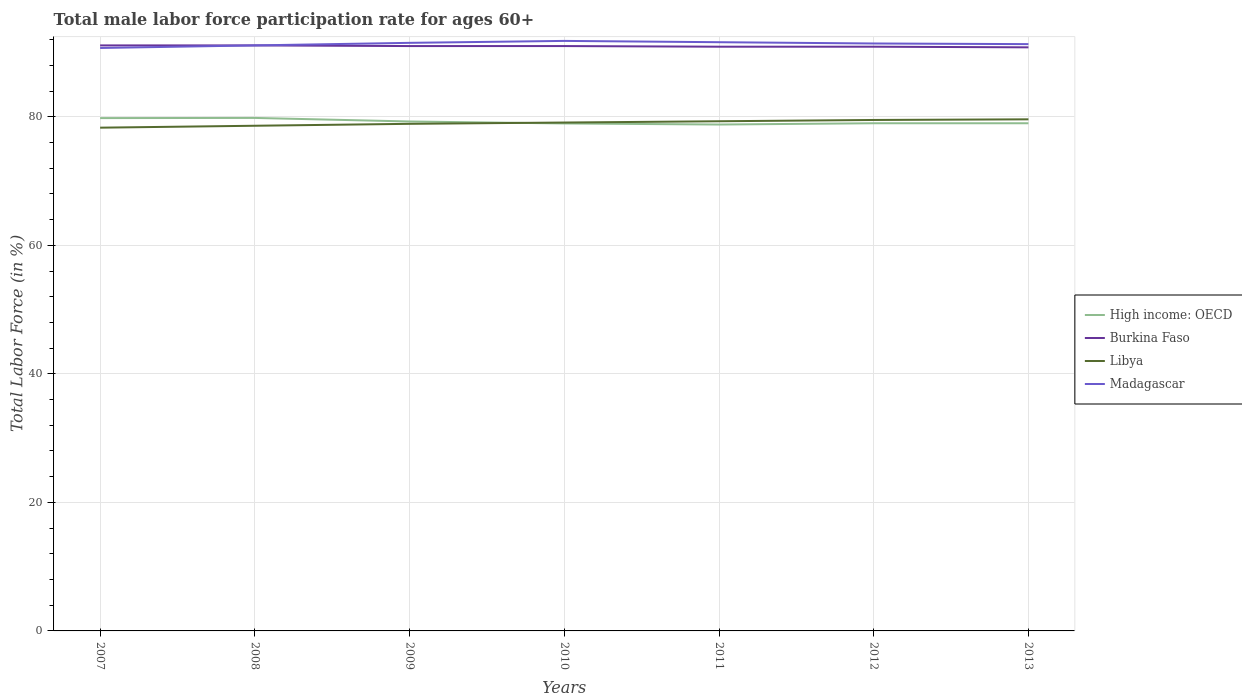Does the line corresponding to Libya intersect with the line corresponding to Madagascar?
Your answer should be very brief. No. Is the number of lines equal to the number of legend labels?
Offer a very short reply. Yes. Across all years, what is the maximum male labor force participation rate in High income: OECD?
Offer a very short reply. 78.79. In which year was the male labor force participation rate in Burkina Faso maximum?
Your response must be concise. 2013. What is the total male labor force participation rate in Burkina Faso in the graph?
Ensure brevity in your answer.  0.1. What is the difference between the highest and the second highest male labor force participation rate in High income: OECD?
Your answer should be very brief. 1.03. Is the male labor force participation rate in Libya strictly greater than the male labor force participation rate in Madagascar over the years?
Provide a succinct answer. Yes. Does the graph contain grids?
Give a very brief answer. Yes. How many legend labels are there?
Provide a succinct answer. 4. What is the title of the graph?
Keep it short and to the point. Total male labor force participation rate for ages 60+. Does "Nepal" appear as one of the legend labels in the graph?
Offer a very short reply. No. What is the label or title of the X-axis?
Your answer should be compact. Years. What is the label or title of the Y-axis?
Your response must be concise. Total Labor Force (in %). What is the Total Labor Force (in %) in High income: OECD in 2007?
Give a very brief answer. 79.79. What is the Total Labor Force (in %) in Burkina Faso in 2007?
Offer a terse response. 91.1. What is the Total Labor Force (in %) in Libya in 2007?
Offer a very short reply. 78.3. What is the Total Labor Force (in %) of Madagascar in 2007?
Keep it short and to the point. 90.7. What is the Total Labor Force (in %) in High income: OECD in 2008?
Make the answer very short. 79.82. What is the Total Labor Force (in %) in Burkina Faso in 2008?
Provide a short and direct response. 91.1. What is the Total Labor Force (in %) in Libya in 2008?
Your answer should be compact. 78.6. What is the Total Labor Force (in %) in Madagascar in 2008?
Ensure brevity in your answer.  91.1. What is the Total Labor Force (in %) of High income: OECD in 2009?
Keep it short and to the point. 79.26. What is the Total Labor Force (in %) in Burkina Faso in 2009?
Give a very brief answer. 91. What is the Total Labor Force (in %) of Libya in 2009?
Provide a succinct answer. 78.9. What is the Total Labor Force (in %) in Madagascar in 2009?
Your response must be concise. 91.5. What is the Total Labor Force (in %) in High income: OECD in 2010?
Make the answer very short. 78.96. What is the Total Labor Force (in %) in Burkina Faso in 2010?
Give a very brief answer. 91. What is the Total Labor Force (in %) in Libya in 2010?
Offer a very short reply. 79.1. What is the Total Labor Force (in %) in Madagascar in 2010?
Offer a terse response. 91.8. What is the Total Labor Force (in %) of High income: OECD in 2011?
Your answer should be compact. 78.79. What is the Total Labor Force (in %) of Burkina Faso in 2011?
Offer a terse response. 90.9. What is the Total Labor Force (in %) of Libya in 2011?
Give a very brief answer. 79.3. What is the Total Labor Force (in %) in Madagascar in 2011?
Offer a very short reply. 91.6. What is the Total Labor Force (in %) in High income: OECD in 2012?
Your response must be concise. 78.99. What is the Total Labor Force (in %) in Burkina Faso in 2012?
Provide a succinct answer. 90.9. What is the Total Labor Force (in %) in Libya in 2012?
Provide a succinct answer. 79.5. What is the Total Labor Force (in %) of Madagascar in 2012?
Offer a terse response. 91.4. What is the Total Labor Force (in %) in High income: OECD in 2013?
Your response must be concise. 78.99. What is the Total Labor Force (in %) of Burkina Faso in 2013?
Make the answer very short. 90.8. What is the Total Labor Force (in %) in Libya in 2013?
Give a very brief answer. 79.6. What is the Total Labor Force (in %) of Madagascar in 2013?
Give a very brief answer. 91.3. Across all years, what is the maximum Total Labor Force (in %) of High income: OECD?
Offer a terse response. 79.82. Across all years, what is the maximum Total Labor Force (in %) in Burkina Faso?
Give a very brief answer. 91.1. Across all years, what is the maximum Total Labor Force (in %) in Libya?
Make the answer very short. 79.6. Across all years, what is the maximum Total Labor Force (in %) of Madagascar?
Offer a very short reply. 91.8. Across all years, what is the minimum Total Labor Force (in %) of High income: OECD?
Offer a very short reply. 78.79. Across all years, what is the minimum Total Labor Force (in %) in Burkina Faso?
Give a very brief answer. 90.8. Across all years, what is the minimum Total Labor Force (in %) in Libya?
Provide a succinct answer. 78.3. Across all years, what is the minimum Total Labor Force (in %) of Madagascar?
Give a very brief answer. 90.7. What is the total Total Labor Force (in %) in High income: OECD in the graph?
Provide a succinct answer. 554.6. What is the total Total Labor Force (in %) of Burkina Faso in the graph?
Offer a very short reply. 636.8. What is the total Total Labor Force (in %) in Libya in the graph?
Keep it short and to the point. 553.3. What is the total Total Labor Force (in %) in Madagascar in the graph?
Offer a terse response. 639.4. What is the difference between the Total Labor Force (in %) of High income: OECD in 2007 and that in 2008?
Your answer should be compact. -0.03. What is the difference between the Total Labor Force (in %) in Libya in 2007 and that in 2008?
Keep it short and to the point. -0.3. What is the difference between the Total Labor Force (in %) in Madagascar in 2007 and that in 2008?
Make the answer very short. -0.4. What is the difference between the Total Labor Force (in %) of High income: OECD in 2007 and that in 2009?
Your answer should be compact. 0.53. What is the difference between the Total Labor Force (in %) of Burkina Faso in 2007 and that in 2009?
Make the answer very short. 0.1. What is the difference between the Total Labor Force (in %) of Madagascar in 2007 and that in 2009?
Offer a very short reply. -0.8. What is the difference between the Total Labor Force (in %) in High income: OECD in 2007 and that in 2010?
Provide a short and direct response. 0.83. What is the difference between the Total Labor Force (in %) of High income: OECD in 2007 and that in 2011?
Make the answer very short. 1. What is the difference between the Total Labor Force (in %) in Burkina Faso in 2007 and that in 2011?
Offer a very short reply. 0.2. What is the difference between the Total Labor Force (in %) of Libya in 2007 and that in 2011?
Offer a terse response. -1. What is the difference between the Total Labor Force (in %) in High income: OECD in 2007 and that in 2012?
Your answer should be compact. 0.8. What is the difference between the Total Labor Force (in %) of Burkina Faso in 2007 and that in 2012?
Your response must be concise. 0.2. What is the difference between the Total Labor Force (in %) of Libya in 2007 and that in 2012?
Your answer should be compact. -1.2. What is the difference between the Total Labor Force (in %) of Madagascar in 2007 and that in 2012?
Ensure brevity in your answer.  -0.7. What is the difference between the Total Labor Force (in %) of High income: OECD in 2007 and that in 2013?
Make the answer very short. 0.8. What is the difference between the Total Labor Force (in %) of Burkina Faso in 2007 and that in 2013?
Make the answer very short. 0.3. What is the difference between the Total Labor Force (in %) in Libya in 2007 and that in 2013?
Your answer should be compact. -1.3. What is the difference between the Total Labor Force (in %) in High income: OECD in 2008 and that in 2009?
Your answer should be compact. 0.56. What is the difference between the Total Labor Force (in %) in High income: OECD in 2008 and that in 2010?
Offer a terse response. 0.86. What is the difference between the Total Labor Force (in %) in Libya in 2008 and that in 2010?
Make the answer very short. -0.5. What is the difference between the Total Labor Force (in %) in High income: OECD in 2008 and that in 2011?
Provide a short and direct response. 1.03. What is the difference between the Total Labor Force (in %) of Burkina Faso in 2008 and that in 2011?
Your answer should be compact. 0.2. What is the difference between the Total Labor Force (in %) of High income: OECD in 2008 and that in 2012?
Offer a very short reply. 0.83. What is the difference between the Total Labor Force (in %) of Burkina Faso in 2008 and that in 2012?
Your answer should be very brief. 0.2. What is the difference between the Total Labor Force (in %) in Libya in 2008 and that in 2012?
Make the answer very short. -0.9. What is the difference between the Total Labor Force (in %) in Madagascar in 2008 and that in 2012?
Provide a succinct answer. -0.3. What is the difference between the Total Labor Force (in %) of High income: OECD in 2008 and that in 2013?
Offer a terse response. 0.83. What is the difference between the Total Labor Force (in %) in Burkina Faso in 2008 and that in 2013?
Ensure brevity in your answer.  0.3. What is the difference between the Total Labor Force (in %) in High income: OECD in 2009 and that in 2010?
Provide a short and direct response. 0.31. What is the difference between the Total Labor Force (in %) of High income: OECD in 2009 and that in 2011?
Offer a very short reply. 0.47. What is the difference between the Total Labor Force (in %) of Libya in 2009 and that in 2011?
Provide a short and direct response. -0.4. What is the difference between the Total Labor Force (in %) in High income: OECD in 2009 and that in 2012?
Your response must be concise. 0.28. What is the difference between the Total Labor Force (in %) in Madagascar in 2009 and that in 2012?
Ensure brevity in your answer.  0.1. What is the difference between the Total Labor Force (in %) in High income: OECD in 2009 and that in 2013?
Provide a short and direct response. 0.27. What is the difference between the Total Labor Force (in %) in Libya in 2009 and that in 2013?
Your response must be concise. -0.7. What is the difference between the Total Labor Force (in %) of High income: OECD in 2010 and that in 2011?
Keep it short and to the point. 0.17. What is the difference between the Total Labor Force (in %) in Libya in 2010 and that in 2011?
Your answer should be compact. -0.2. What is the difference between the Total Labor Force (in %) of Madagascar in 2010 and that in 2011?
Your response must be concise. 0.2. What is the difference between the Total Labor Force (in %) in High income: OECD in 2010 and that in 2012?
Provide a short and direct response. -0.03. What is the difference between the Total Labor Force (in %) in Libya in 2010 and that in 2012?
Ensure brevity in your answer.  -0.4. What is the difference between the Total Labor Force (in %) in High income: OECD in 2010 and that in 2013?
Ensure brevity in your answer.  -0.03. What is the difference between the Total Labor Force (in %) of Burkina Faso in 2010 and that in 2013?
Provide a succinct answer. 0.2. What is the difference between the Total Labor Force (in %) in High income: OECD in 2011 and that in 2012?
Give a very brief answer. -0.2. What is the difference between the Total Labor Force (in %) in High income: OECD in 2011 and that in 2013?
Offer a very short reply. -0.2. What is the difference between the Total Labor Force (in %) of Burkina Faso in 2011 and that in 2013?
Offer a terse response. 0.1. What is the difference between the Total Labor Force (in %) in Madagascar in 2011 and that in 2013?
Keep it short and to the point. 0.3. What is the difference between the Total Labor Force (in %) in High income: OECD in 2012 and that in 2013?
Your answer should be compact. -0. What is the difference between the Total Labor Force (in %) of Libya in 2012 and that in 2013?
Keep it short and to the point. -0.1. What is the difference between the Total Labor Force (in %) of High income: OECD in 2007 and the Total Labor Force (in %) of Burkina Faso in 2008?
Give a very brief answer. -11.31. What is the difference between the Total Labor Force (in %) of High income: OECD in 2007 and the Total Labor Force (in %) of Libya in 2008?
Your answer should be compact. 1.19. What is the difference between the Total Labor Force (in %) in High income: OECD in 2007 and the Total Labor Force (in %) in Madagascar in 2008?
Provide a short and direct response. -11.31. What is the difference between the Total Labor Force (in %) of Libya in 2007 and the Total Labor Force (in %) of Madagascar in 2008?
Your answer should be very brief. -12.8. What is the difference between the Total Labor Force (in %) in High income: OECD in 2007 and the Total Labor Force (in %) in Burkina Faso in 2009?
Ensure brevity in your answer.  -11.21. What is the difference between the Total Labor Force (in %) of High income: OECD in 2007 and the Total Labor Force (in %) of Libya in 2009?
Offer a terse response. 0.89. What is the difference between the Total Labor Force (in %) of High income: OECD in 2007 and the Total Labor Force (in %) of Madagascar in 2009?
Offer a terse response. -11.71. What is the difference between the Total Labor Force (in %) of Burkina Faso in 2007 and the Total Labor Force (in %) of Madagascar in 2009?
Provide a short and direct response. -0.4. What is the difference between the Total Labor Force (in %) in High income: OECD in 2007 and the Total Labor Force (in %) in Burkina Faso in 2010?
Your answer should be compact. -11.21. What is the difference between the Total Labor Force (in %) of High income: OECD in 2007 and the Total Labor Force (in %) of Libya in 2010?
Provide a short and direct response. 0.69. What is the difference between the Total Labor Force (in %) of High income: OECD in 2007 and the Total Labor Force (in %) of Madagascar in 2010?
Provide a short and direct response. -12.01. What is the difference between the Total Labor Force (in %) in Libya in 2007 and the Total Labor Force (in %) in Madagascar in 2010?
Offer a very short reply. -13.5. What is the difference between the Total Labor Force (in %) in High income: OECD in 2007 and the Total Labor Force (in %) in Burkina Faso in 2011?
Your answer should be compact. -11.11. What is the difference between the Total Labor Force (in %) of High income: OECD in 2007 and the Total Labor Force (in %) of Libya in 2011?
Your answer should be very brief. 0.49. What is the difference between the Total Labor Force (in %) of High income: OECD in 2007 and the Total Labor Force (in %) of Madagascar in 2011?
Your answer should be very brief. -11.81. What is the difference between the Total Labor Force (in %) in Burkina Faso in 2007 and the Total Labor Force (in %) in Madagascar in 2011?
Provide a succinct answer. -0.5. What is the difference between the Total Labor Force (in %) of Libya in 2007 and the Total Labor Force (in %) of Madagascar in 2011?
Offer a terse response. -13.3. What is the difference between the Total Labor Force (in %) in High income: OECD in 2007 and the Total Labor Force (in %) in Burkina Faso in 2012?
Your response must be concise. -11.11. What is the difference between the Total Labor Force (in %) in High income: OECD in 2007 and the Total Labor Force (in %) in Libya in 2012?
Provide a succinct answer. 0.29. What is the difference between the Total Labor Force (in %) of High income: OECD in 2007 and the Total Labor Force (in %) of Madagascar in 2012?
Offer a very short reply. -11.61. What is the difference between the Total Labor Force (in %) of Burkina Faso in 2007 and the Total Labor Force (in %) of Libya in 2012?
Make the answer very short. 11.6. What is the difference between the Total Labor Force (in %) of Burkina Faso in 2007 and the Total Labor Force (in %) of Madagascar in 2012?
Your answer should be compact. -0.3. What is the difference between the Total Labor Force (in %) in Libya in 2007 and the Total Labor Force (in %) in Madagascar in 2012?
Offer a very short reply. -13.1. What is the difference between the Total Labor Force (in %) in High income: OECD in 2007 and the Total Labor Force (in %) in Burkina Faso in 2013?
Make the answer very short. -11.01. What is the difference between the Total Labor Force (in %) of High income: OECD in 2007 and the Total Labor Force (in %) of Libya in 2013?
Make the answer very short. 0.19. What is the difference between the Total Labor Force (in %) in High income: OECD in 2007 and the Total Labor Force (in %) in Madagascar in 2013?
Your answer should be compact. -11.51. What is the difference between the Total Labor Force (in %) of Burkina Faso in 2007 and the Total Labor Force (in %) of Libya in 2013?
Offer a very short reply. 11.5. What is the difference between the Total Labor Force (in %) in Burkina Faso in 2007 and the Total Labor Force (in %) in Madagascar in 2013?
Your response must be concise. -0.2. What is the difference between the Total Labor Force (in %) of Libya in 2007 and the Total Labor Force (in %) of Madagascar in 2013?
Give a very brief answer. -13. What is the difference between the Total Labor Force (in %) in High income: OECD in 2008 and the Total Labor Force (in %) in Burkina Faso in 2009?
Provide a short and direct response. -11.18. What is the difference between the Total Labor Force (in %) of High income: OECD in 2008 and the Total Labor Force (in %) of Libya in 2009?
Give a very brief answer. 0.92. What is the difference between the Total Labor Force (in %) in High income: OECD in 2008 and the Total Labor Force (in %) in Madagascar in 2009?
Provide a succinct answer. -11.68. What is the difference between the Total Labor Force (in %) of Burkina Faso in 2008 and the Total Labor Force (in %) of Madagascar in 2009?
Provide a short and direct response. -0.4. What is the difference between the Total Labor Force (in %) of Libya in 2008 and the Total Labor Force (in %) of Madagascar in 2009?
Offer a terse response. -12.9. What is the difference between the Total Labor Force (in %) in High income: OECD in 2008 and the Total Labor Force (in %) in Burkina Faso in 2010?
Keep it short and to the point. -11.18. What is the difference between the Total Labor Force (in %) in High income: OECD in 2008 and the Total Labor Force (in %) in Libya in 2010?
Offer a very short reply. 0.72. What is the difference between the Total Labor Force (in %) in High income: OECD in 2008 and the Total Labor Force (in %) in Madagascar in 2010?
Give a very brief answer. -11.98. What is the difference between the Total Labor Force (in %) of Burkina Faso in 2008 and the Total Labor Force (in %) of Madagascar in 2010?
Your answer should be compact. -0.7. What is the difference between the Total Labor Force (in %) of Libya in 2008 and the Total Labor Force (in %) of Madagascar in 2010?
Offer a terse response. -13.2. What is the difference between the Total Labor Force (in %) in High income: OECD in 2008 and the Total Labor Force (in %) in Burkina Faso in 2011?
Offer a very short reply. -11.08. What is the difference between the Total Labor Force (in %) in High income: OECD in 2008 and the Total Labor Force (in %) in Libya in 2011?
Your answer should be very brief. 0.52. What is the difference between the Total Labor Force (in %) of High income: OECD in 2008 and the Total Labor Force (in %) of Madagascar in 2011?
Your response must be concise. -11.78. What is the difference between the Total Labor Force (in %) of Burkina Faso in 2008 and the Total Labor Force (in %) of Libya in 2011?
Make the answer very short. 11.8. What is the difference between the Total Labor Force (in %) in Burkina Faso in 2008 and the Total Labor Force (in %) in Madagascar in 2011?
Make the answer very short. -0.5. What is the difference between the Total Labor Force (in %) of Libya in 2008 and the Total Labor Force (in %) of Madagascar in 2011?
Offer a very short reply. -13. What is the difference between the Total Labor Force (in %) of High income: OECD in 2008 and the Total Labor Force (in %) of Burkina Faso in 2012?
Your answer should be very brief. -11.08. What is the difference between the Total Labor Force (in %) of High income: OECD in 2008 and the Total Labor Force (in %) of Libya in 2012?
Provide a succinct answer. 0.32. What is the difference between the Total Labor Force (in %) of High income: OECD in 2008 and the Total Labor Force (in %) of Madagascar in 2012?
Your answer should be very brief. -11.58. What is the difference between the Total Labor Force (in %) of High income: OECD in 2008 and the Total Labor Force (in %) of Burkina Faso in 2013?
Your answer should be compact. -10.98. What is the difference between the Total Labor Force (in %) of High income: OECD in 2008 and the Total Labor Force (in %) of Libya in 2013?
Keep it short and to the point. 0.22. What is the difference between the Total Labor Force (in %) in High income: OECD in 2008 and the Total Labor Force (in %) in Madagascar in 2013?
Provide a short and direct response. -11.48. What is the difference between the Total Labor Force (in %) of Burkina Faso in 2008 and the Total Labor Force (in %) of Madagascar in 2013?
Keep it short and to the point. -0.2. What is the difference between the Total Labor Force (in %) in Libya in 2008 and the Total Labor Force (in %) in Madagascar in 2013?
Give a very brief answer. -12.7. What is the difference between the Total Labor Force (in %) in High income: OECD in 2009 and the Total Labor Force (in %) in Burkina Faso in 2010?
Provide a short and direct response. -11.74. What is the difference between the Total Labor Force (in %) in High income: OECD in 2009 and the Total Labor Force (in %) in Libya in 2010?
Provide a short and direct response. 0.16. What is the difference between the Total Labor Force (in %) of High income: OECD in 2009 and the Total Labor Force (in %) of Madagascar in 2010?
Provide a short and direct response. -12.54. What is the difference between the Total Labor Force (in %) in Burkina Faso in 2009 and the Total Labor Force (in %) in Madagascar in 2010?
Provide a short and direct response. -0.8. What is the difference between the Total Labor Force (in %) of High income: OECD in 2009 and the Total Labor Force (in %) of Burkina Faso in 2011?
Give a very brief answer. -11.64. What is the difference between the Total Labor Force (in %) in High income: OECD in 2009 and the Total Labor Force (in %) in Libya in 2011?
Offer a terse response. -0.04. What is the difference between the Total Labor Force (in %) in High income: OECD in 2009 and the Total Labor Force (in %) in Madagascar in 2011?
Offer a very short reply. -12.34. What is the difference between the Total Labor Force (in %) in Burkina Faso in 2009 and the Total Labor Force (in %) in Libya in 2011?
Provide a short and direct response. 11.7. What is the difference between the Total Labor Force (in %) of Burkina Faso in 2009 and the Total Labor Force (in %) of Madagascar in 2011?
Offer a very short reply. -0.6. What is the difference between the Total Labor Force (in %) in High income: OECD in 2009 and the Total Labor Force (in %) in Burkina Faso in 2012?
Keep it short and to the point. -11.64. What is the difference between the Total Labor Force (in %) in High income: OECD in 2009 and the Total Labor Force (in %) in Libya in 2012?
Offer a terse response. -0.24. What is the difference between the Total Labor Force (in %) in High income: OECD in 2009 and the Total Labor Force (in %) in Madagascar in 2012?
Offer a very short reply. -12.14. What is the difference between the Total Labor Force (in %) in Libya in 2009 and the Total Labor Force (in %) in Madagascar in 2012?
Give a very brief answer. -12.5. What is the difference between the Total Labor Force (in %) in High income: OECD in 2009 and the Total Labor Force (in %) in Burkina Faso in 2013?
Your answer should be very brief. -11.54. What is the difference between the Total Labor Force (in %) in High income: OECD in 2009 and the Total Labor Force (in %) in Libya in 2013?
Offer a terse response. -0.34. What is the difference between the Total Labor Force (in %) in High income: OECD in 2009 and the Total Labor Force (in %) in Madagascar in 2013?
Offer a terse response. -12.04. What is the difference between the Total Labor Force (in %) of Libya in 2009 and the Total Labor Force (in %) of Madagascar in 2013?
Provide a succinct answer. -12.4. What is the difference between the Total Labor Force (in %) of High income: OECD in 2010 and the Total Labor Force (in %) of Burkina Faso in 2011?
Your answer should be compact. -11.94. What is the difference between the Total Labor Force (in %) of High income: OECD in 2010 and the Total Labor Force (in %) of Libya in 2011?
Provide a succinct answer. -0.34. What is the difference between the Total Labor Force (in %) in High income: OECD in 2010 and the Total Labor Force (in %) in Madagascar in 2011?
Offer a terse response. -12.64. What is the difference between the Total Labor Force (in %) of Burkina Faso in 2010 and the Total Labor Force (in %) of Madagascar in 2011?
Your answer should be compact. -0.6. What is the difference between the Total Labor Force (in %) in High income: OECD in 2010 and the Total Labor Force (in %) in Burkina Faso in 2012?
Keep it short and to the point. -11.94. What is the difference between the Total Labor Force (in %) in High income: OECD in 2010 and the Total Labor Force (in %) in Libya in 2012?
Make the answer very short. -0.54. What is the difference between the Total Labor Force (in %) of High income: OECD in 2010 and the Total Labor Force (in %) of Madagascar in 2012?
Provide a short and direct response. -12.44. What is the difference between the Total Labor Force (in %) of Burkina Faso in 2010 and the Total Labor Force (in %) of Libya in 2012?
Keep it short and to the point. 11.5. What is the difference between the Total Labor Force (in %) in High income: OECD in 2010 and the Total Labor Force (in %) in Burkina Faso in 2013?
Provide a short and direct response. -11.84. What is the difference between the Total Labor Force (in %) of High income: OECD in 2010 and the Total Labor Force (in %) of Libya in 2013?
Give a very brief answer. -0.64. What is the difference between the Total Labor Force (in %) of High income: OECD in 2010 and the Total Labor Force (in %) of Madagascar in 2013?
Keep it short and to the point. -12.34. What is the difference between the Total Labor Force (in %) in High income: OECD in 2011 and the Total Labor Force (in %) in Burkina Faso in 2012?
Your response must be concise. -12.11. What is the difference between the Total Labor Force (in %) in High income: OECD in 2011 and the Total Labor Force (in %) in Libya in 2012?
Your response must be concise. -0.71. What is the difference between the Total Labor Force (in %) in High income: OECD in 2011 and the Total Labor Force (in %) in Madagascar in 2012?
Provide a short and direct response. -12.61. What is the difference between the Total Labor Force (in %) of Burkina Faso in 2011 and the Total Labor Force (in %) of Madagascar in 2012?
Give a very brief answer. -0.5. What is the difference between the Total Labor Force (in %) of Libya in 2011 and the Total Labor Force (in %) of Madagascar in 2012?
Keep it short and to the point. -12.1. What is the difference between the Total Labor Force (in %) in High income: OECD in 2011 and the Total Labor Force (in %) in Burkina Faso in 2013?
Offer a terse response. -12.01. What is the difference between the Total Labor Force (in %) of High income: OECD in 2011 and the Total Labor Force (in %) of Libya in 2013?
Give a very brief answer. -0.81. What is the difference between the Total Labor Force (in %) in High income: OECD in 2011 and the Total Labor Force (in %) in Madagascar in 2013?
Ensure brevity in your answer.  -12.51. What is the difference between the Total Labor Force (in %) in Burkina Faso in 2011 and the Total Labor Force (in %) in Madagascar in 2013?
Ensure brevity in your answer.  -0.4. What is the difference between the Total Labor Force (in %) of High income: OECD in 2012 and the Total Labor Force (in %) of Burkina Faso in 2013?
Provide a succinct answer. -11.81. What is the difference between the Total Labor Force (in %) of High income: OECD in 2012 and the Total Labor Force (in %) of Libya in 2013?
Your answer should be compact. -0.61. What is the difference between the Total Labor Force (in %) of High income: OECD in 2012 and the Total Labor Force (in %) of Madagascar in 2013?
Your answer should be compact. -12.31. What is the difference between the Total Labor Force (in %) of Burkina Faso in 2012 and the Total Labor Force (in %) of Libya in 2013?
Offer a terse response. 11.3. What is the average Total Labor Force (in %) of High income: OECD per year?
Your answer should be very brief. 79.23. What is the average Total Labor Force (in %) in Burkina Faso per year?
Give a very brief answer. 90.97. What is the average Total Labor Force (in %) of Libya per year?
Make the answer very short. 79.04. What is the average Total Labor Force (in %) of Madagascar per year?
Provide a short and direct response. 91.34. In the year 2007, what is the difference between the Total Labor Force (in %) in High income: OECD and Total Labor Force (in %) in Burkina Faso?
Your answer should be compact. -11.31. In the year 2007, what is the difference between the Total Labor Force (in %) in High income: OECD and Total Labor Force (in %) in Libya?
Offer a terse response. 1.49. In the year 2007, what is the difference between the Total Labor Force (in %) of High income: OECD and Total Labor Force (in %) of Madagascar?
Your response must be concise. -10.91. In the year 2008, what is the difference between the Total Labor Force (in %) of High income: OECD and Total Labor Force (in %) of Burkina Faso?
Offer a terse response. -11.28. In the year 2008, what is the difference between the Total Labor Force (in %) in High income: OECD and Total Labor Force (in %) in Libya?
Offer a terse response. 1.22. In the year 2008, what is the difference between the Total Labor Force (in %) in High income: OECD and Total Labor Force (in %) in Madagascar?
Make the answer very short. -11.28. In the year 2008, what is the difference between the Total Labor Force (in %) of Burkina Faso and Total Labor Force (in %) of Madagascar?
Keep it short and to the point. 0. In the year 2008, what is the difference between the Total Labor Force (in %) in Libya and Total Labor Force (in %) in Madagascar?
Give a very brief answer. -12.5. In the year 2009, what is the difference between the Total Labor Force (in %) in High income: OECD and Total Labor Force (in %) in Burkina Faso?
Make the answer very short. -11.74. In the year 2009, what is the difference between the Total Labor Force (in %) of High income: OECD and Total Labor Force (in %) of Libya?
Provide a short and direct response. 0.36. In the year 2009, what is the difference between the Total Labor Force (in %) of High income: OECD and Total Labor Force (in %) of Madagascar?
Provide a short and direct response. -12.24. In the year 2010, what is the difference between the Total Labor Force (in %) of High income: OECD and Total Labor Force (in %) of Burkina Faso?
Your answer should be compact. -12.04. In the year 2010, what is the difference between the Total Labor Force (in %) of High income: OECD and Total Labor Force (in %) of Libya?
Your answer should be very brief. -0.14. In the year 2010, what is the difference between the Total Labor Force (in %) in High income: OECD and Total Labor Force (in %) in Madagascar?
Keep it short and to the point. -12.84. In the year 2010, what is the difference between the Total Labor Force (in %) of Burkina Faso and Total Labor Force (in %) of Libya?
Your answer should be very brief. 11.9. In the year 2010, what is the difference between the Total Labor Force (in %) of Burkina Faso and Total Labor Force (in %) of Madagascar?
Make the answer very short. -0.8. In the year 2010, what is the difference between the Total Labor Force (in %) of Libya and Total Labor Force (in %) of Madagascar?
Your answer should be compact. -12.7. In the year 2011, what is the difference between the Total Labor Force (in %) of High income: OECD and Total Labor Force (in %) of Burkina Faso?
Keep it short and to the point. -12.11. In the year 2011, what is the difference between the Total Labor Force (in %) of High income: OECD and Total Labor Force (in %) of Libya?
Give a very brief answer. -0.51. In the year 2011, what is the difference between the Total Labor Force (in %) in High income: OECD and Total Labor Force (in %) in Madagascar?
Offer a terse response. -12.81. In the year 2011, what is the difference between the Total Labor Force (in %) of Burkina Faso and Total Labor Force (in %) of Libya?
Your response must be concise. 11.6. In the year 2012, what is the difference between the Total Labor Force (in %) of High income: OECD and Total Labor Force (in %) of Burkina Faso?
Your response must be concise. -11.91. In the year 2012, what is the difference between the Total Labor Force (in %) of High income: OECD and Total Labor Force (in %) of Libya?
Your response must be concise. -0.51. In the year 2012, what is the difference between the Total Labor Force (in %) in High income: OECD and Total Labor Force (in %) in Madagascar?
Offer a very short reply. -12.41. In the year 2012, what is the difference between the Total Labor Force (in %) in Burkina Faso and Total Labor Force (in %) in Libya?
Your response must be concise. 11.4. In the year 2012, what is the difference between the Total Labor Force (in %) in Burkina Faso and Total Labor Force (in %) in Madagascar?
Your answer should be very brief. -0.5. In the year 2012, what is the difference between the Total Labor Force (in %) of Libya and Total Labor Force (in %) of Madagascar?
Make the answer very short. -11.9. In the year 2013, what is the difference between the Total Labor Force (in %) of High income: OECD and Total Labor Force (in %) of Burkina Faso?
Offer a very short reply. -11.81. In the year 2013, what is the difference between the Total Labor Force (in %) of High income: OECD and Total Labor Force (in %) of Libya?
Give a very brief answer. -0.61. In the year 2013, what is the difference between the Total Labor Force (in %) of High income: OECD and Total Labor Force (in %) of Madagascar?
Offer a very short reply. -12.31. In the year 2013, what is the difference between the Total Labor Force (in %) in Burkina Faso and Total Labor Force (in %) in Libya?
Your answer should be compact. 11.2. In the year 2013, what is the difference between the Total Labor Force (in %) in Burkina Faso and Total Labor Force (in %) in Madagascar?
Your answer should be compact. -0.5. In the year 2013, what is the difference between the Total Labor Force (in %) of Libya and Total Labor Force (in %) of Madagascar?
Give a very brief answer. -11.7. What is the ratio of the Total Labor Force (in %) in High income: OECD in 2007 to that in 2008?
Your response must be concise. 1. What is the ratio of the Total Labor Force (in %) of Burkina Faso in 2007 to that in 2008?
Provide a succinct answer. 1. What is the ratio of the Total Labor Force (in %) of Madagascar in 2007 to that in 2008?
Make the answer very short. 1. What is the ratio of the Total Labor Force (in %) in Burkina Faso in 2007 to that in 2009?
Provide a short and direct response. 1. What is the ratio of the Total Labor Force (in %) in Libya in 2007 to that in 2009?
Give a very brief answer. 0.99. What is the ratio of the Total Labor Force (in %) in Madagascar in 2007 to that in 2009?
Your response must be concise. 0.99. What is the ratio of the Total Labor Force (in %) in High income: OECD in 2007 to that in 2010?
Provide a succinct answer. 1.01. What is the ratio of the Total Labor Force (in %) in Burkina Faso in 2007 to that in 2010?
Keep it short and to the point. 1. What is the ratio of the Total Labor Force (in %) in Libya in 2007 to that in 2010?
Offer a very short reply. 0.99. What is the ratio of the Total Labor Force (in %) of Madagascar in 2007 to that in 2010?
Offer a very short reply. 0.99. What is the ratio of the Total Labor Force (in %) of High income: OECD in 2007 to that in 2011?
Make the answer very short. 1.01. What is the ratio of the Total Labor Force (in %) of Burkina Faso in 2007 to that in 2011?
Keep it short and to the point. 1. What is the ratio of the Total Labor Force (in %) of Libya in 2007 to that in 2011?
Offer a very short reply. 0.99. What is the ratio of the Total Labor Force (in %) in Madagascar in 2007 to that in 2011?
Your answer should be very brief. 0.99. What is the ratio of the Total Labor Force (in %) in High income: OECD in 2007 to that in 2012?
Ensure brevity in your answer.  1.01. What is the ratio of the Total Labor Force (in %) of Libya in 2007 to that in 2012?
Provide a succinct answer. 0.98. What is the ratio of the Total Labor Force (in %) in Madagascar in 2007 to that in 2012?
Offer a very short reply. 0.99. What is the ratio of the Total Labor Force (in %) in Burkina Faso in 2007 to that in 2013?
Ensure brevity in your answer.  1. What is the ratio of the Total Labor Force (in %) in Libya in 2007 to that in 2013?
Your answer should be very brief. 0.98. What is the ratio of the Total Labor Force (in %) in High income: OECD in 2008 to that in 2009?
Offer a very short reply. 1.01. What is the ratio of the Total Labor Force (in %) in High income: OECD in 2008 to that in 2010?
Ensure brevity in your answer.  1.01. What is the ratio of the Total Labor Force (in %) of Burkina Faso in 2008 to that in 2010?
Give a very brief answer. 1. What is the ratio of the Total Labor Force (in %) of Libya in 2008 to that in 2010?
Your answer should be compact. 0.99. What is the ratio of the Total Labor Force (in %) in Madagascar in 2008 to that in 2010?
Provide a succinct answer. 0.99. What is the ratio of the Total Labor Force (in %) of High income: OECD in 2008 to that in 2011?
Offer a very short reply. 1.01. What is the ratio of the Total Labor Force (in %) in Madagascar in 2008 to that in 2011?
Keep it short and to the point. 0.99. What is the ratio of the Total Labor Force (in %) of High income: OECD in 2008 to that in 2012?
Provide a short and direct response. 1.01. What is the ratio of the Total Labor Force (in %) of Burkina Faso in 2008 to that in 2012?
Offer a terse response. 1. What is the ratio of the Total Labor Force (in %) in Libya in 2008 to that in 2012?
Make the answer very short. 0.99. What is the ratio of the Total Labor Force (in %) of High income: OECD in 2008 to that in 2013?
Provide a short and direct response. 1.01. What is the ratio of the Total Labor Force (in %) in Burkina Faso in 2008 to that in 2013?
Your answer should be compact. 1. What is the ratio of the Total Labor Force (in %) of Libya in 2008 to that in 2013?
Your answer should be compact. 0.99. What is the ratio of the Total Labor Force (in %) in High income: OECD in 2009 to that in 2010?
Provide a short and direct response. 1. What is the ratio of the Total Labor Force (in %) of Libya in 2009 to that in 2010?
Your answer should be very brief. 1. What is the ratio of the Total Labor Force (in %) in High income: OECD in 2009 to that in 2011?
Your answer should be very brief. 1.01. What is the ratio of the Total Labor Force (in %) in Libya in 2009 to that in 2011?
Offer a terse response. 0.99. What is the ratio of the Total Labor Force (in %) of Madagascar in 2009 to that in 2012?
Keep it short and to the point. 1. What is the ratio of the Total Labor Force (in %) in Libya in 2009 to that in 2013?
Provide a short and direct response. 0.99. What is the ratio of the Total Labor Force (in %) in Libya in 2010 to that in 2012?
Offer a very short reply. 0.99. What is the ratio of the Total Labor Force (in %) in Madagascar in 2010 to that in 2012?
Ensure brevity in your answer.  1. What is the ratio of the Total Labor Force (in %) in Libya in 2010 to that in 2013?
Your answer should be very brief. 0.99. What is the ratio of the Total Labor Force (in %) in High income: OECD in 2011 to that in 2012?
Your response must be concise. 1. What is the ratio of the Total Labor Force (in %) of High income: OECD in 2011 to that in 2013?
Your response must be concise. 1. What is the ratio of the Total Labor Force (in %) in Libya in 2011 to that in 2013?
Offer a very short reply. 1. What is the ratio of the Total Labor Force (in %) in Madagascar in 2011 to that in 2013?
Give a very brief answer. 1. What is the ratio of the Total Labor Force (in %) in High income: OECD in 2012 to that in 2013?
Ensure brevity in your answer.  1. What is the ratio of the Total Labor Force (in %) in Burkina Faso in 2012 to that in 2013?
Provide a succinct answer. 1. What is the difference between the highest and the second highest Total Labor Force (in %) in High income: OECD?
Give a very brief answer. 0.03. What is the difference between the highest and the lowest Total Labor Force (in %) of High income: OECD?
Make the answer very short. 1.03. What is the difference between the highest and the lowest Total Labor Force (in %) in Libya?
Your answer should be very brief. 1.3. What is the difference between the highest and the lowest Total Labor Force (in %) in Madagascar?
Ensure brevity in your answer.  1.1. 